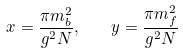<formula> <loc_0><loc_0><loc_500><loc_500>x = \frac { \pi m _ { b } ^ { 2 } } { g ^ { 2 } N } , \quad y = \frac { \pi m _ { f } ^ { 2 } } { g ^ { 2 } N }</formula> 